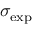<formula> <loc_0><loc_0><loc_500><loc_500>\sigma _ { e x p }</formula> 